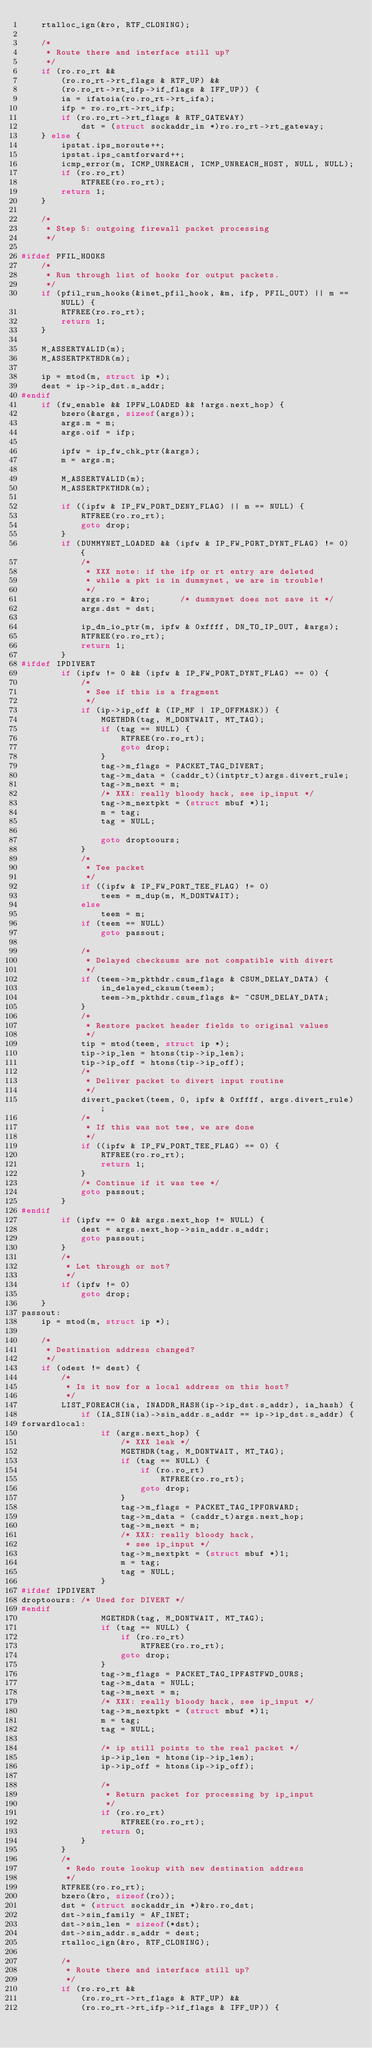Convert code to text. <code><loc_0><loc_0><loc_500><loc_500><_C_>	rtalloc_ign(&ro, RTF_CLONING);

	/*
	 * Route there and interface still up?
	 */
	if (ro.ro_rt &&
	    (ro.ro_rt->rt_flags & RTF_UP) &&
	    (ro.ro_rt->rt_ifp->if_flags & IFF_UP)) {
		ia = ifatoia(ro.ro_rt->rt_ifa);
		ifp = ro.ro_rt->rt_ifp;
		if (ro.ro_rt->rt_flags & RTF_GATEWAY)
			dst = (struct sockaddr_in *)ro.ro_rt->rt_gateway;
	} else {
		ipstat.ips_noroute++;
		ipstat.ips_cantforward++;
		icmp_error(m, ICMP_UNREACH, ICMP_UNREACH_HOST, NULL, NULL);
		if (ro.ro_rt)
			RTFREE(ro.ro_rt);
		return 1;
	}

	/*
	 * Step 5: outgoing firewall packet processing
	 */

#ifdef PFIL_HOOKS
	/*
	 * Run through list of hooks for output packets.
	 */
	if (pfil_run_hooks(&inet_pfil_hook, &m, ifp, PFIL_OUT) || m == NULL) {
		RTFREE(ro.ro_rt);
		return 1;
	}

	M_ASSERTVALID(m);
	M_ASSERTPKTHDR(m);

	ip = mtod(m, struct ip *);
	dest = ip->ip_dst.s_addr;
#endif
	if (fw_enable && IPFW_LOADED && !args.next_hop) {
		bzero(&args, sizeof(args));
		args.m = m;
		args.oif = ifp;

		ipfw = ip_fw_chk_ptr(&args);
		m = args.m;

		M_ASSERTVALID(m);
		M_ASSERTPKTHDR(m);

		if ((ipfw & IP_FW_PORT_DENY_FLAG) || m == NULL) {
			RTFREE(ro.ro_rt);
			goto drop;
		}
		if (DUMMYNET_LOADED && (ipfw & IP_FW_PORT_DYNT_FLAG) != 0) {
			/*
			 * XXX note: if the ifp or rt entry are deleted
			 * while a pkt is in dummynet, we are in trouble!
			 */
			args.ro = &ro;		/* dummynet does not save it */
			args.dst = dst;

			ip_dn_io_ptr(m, ipfw & 0xffff, DN_TO_IP_OUT, &args);
			RTFREE(ro.ro_rt);
			return 1;
		}
#ifdef IPDIVERT
		if (ipfw != 0 && (ipfw & IP_FW_PORT_DYNT_FLAG) == 0) {
			/*
			 * See if this is a fragment
			 */
			if (ip->ip_off & (IP_MF | IP_OFFMASK)) {
				MGETHDR(tag, M_DONTWAIT, MT_TAG);
				if (tag == NULL) {
					RTFREE(ro.ro_rt);
					goto drop;
				}
				tag->m_flags = PACKET_TAG_DIVERT;
				tag->m_data = (caddr_t)(intptr_t)args.divert_rule;
				tag->m_next = m;
				/* XXX: really bloody hack, see ip_input */
				tag->m_nextpkt = (struct mbuf *)1;
				m = tag;
				tag = NULL;

				goto droptoours;
			}
			/*
			 * Tee packet
			 */
			if ((ipfw & IP_FW_PORT_TEE_FLAG) != 0)
				teem = m_dup(m, M_DONTWAIT);
			else
				teem = m;
			if (teem == NULL)
				goto passout;

			/*
			 * Delayed checksums are not compatible with divert
			 */
			if (teem->m_pkthdr.csum_flags & CSUM_DELAY_DATA) {
				in_delayed_cksum(teem);
				teem->m_pkthdr.csum_flags &= ~CSUM_DELAY_DATA;
			}
			/*
			 * Restore packet header fields to original values
			 */
			tip = mtod(teem, struct ip *);
			tip->ip_len = htons(tip->ip_len);
			tip->ip_off = htons(tip->ip_off);
			/*
			 * Deliver packet to divert input routine
			 */
			divert_packet(teem, 0, ipfw & 0xffff, args.divert_rule);
			/*
			 * If this was not tee, we are done
			 */
			if ((ipfw & IP_FW_PORT_TEE_FLAG) == 0) {
				RTFREE(ro.ro_rt);
				return 1;
			}
			/* Continue if it was tee */
			goto passout;
		}
#endif
		if (ipfw == 0 && args.next_hop != NULL) {
			dest = args.next_hop->sin_addr.s_addr;
			goto passout;
		}
		/*
		 * Let through or not?
		 */
		if (ipfw != 0)
			goto drop;
	}
passout:
	ip = mtod(m, struct ip *);

	/*
	 * Destination address changed?
	 */
	if (odest != dest) {
		/*
		 * Is it now for a local address on this host?
		 */
		LIST_FOREACH(ia, INADDR_HASH(ip->ip_dst.s_addr), ia_hash) {
			if (IA_SIN(ia)->sin_addr.s_addr == ip->ip_dst.s_addr) {
forwardlocal:
				if (args.next_hop) {
					/* XXX leak */
					MGETHDR(tag, M_DONTWAIT, MT_TAG);
					if (tag == NULL) {
						if (ro.ro_rt)
							RTFREE(ro.ro_rt);
						goto drop;
					}
					tag->m_flags = PACKET_TAG_IPFORWARD;
					tag->m_data = (caddr_t)args.next_hop;
					tag->m_next = m;
					/* XXX: really bloody hack,
					 * see ip_input */
					tag->m_nextpkt = (struct mbuf *)1;
					m = tag;
					tag = NULL;
				}
#ifdef IPDIVERT
droptoours:	/* Used for DIVERT */
#endif
				MGETHDR(tag, M_DONTWAIT, MT_TAG);
				if (tag == NULL) {
					if (ro.ro_rt)
						RTFREE(ro.ro_rt);
					goto drop;
				}
				tag->m_flags = PACKET_TAG_IPFASTFWD_OURS;
				tag->m_data = NULL;
				tag->m_next = m;
				/* XXX: really bloody hack, see ip_input */
				tag->m_nextpkt = (struct mbuf *)1;
				m = tag;
				tag = NULL;

				/* ip still points to the real packet */
				ip->ip_len = htons(ip->ip_len);
				ip->ip_off = htons(ip->ip_off);

				/*
				 * Return packet for processing by ip_input
				 */
				if (ro.ro_rt)
					RTFREE(ro.ro_rt);
				return 0;
			}
		}
		/*
		 * Redo route lookup with new destination address
		 */
		RTFREE(ro.ro_rt);
		bzero(&ro, sizeof(ro));
		dst = (struct sockaddr_in *)&ro.ro_dst;
		dst->sin_family = AF_INET;
		dst->sin_len = sizeof(*dst);
		dst->sin_addr.s_addr = dest;
		rtalloc_ign(&ro, RTF_CLONING);

		/*
		 * Route there and interface still up?
		 */
		if (ro.ro_rt &&
		    (ro.ro_rt->rt_flags & RTF_UP) &&
		    (ro.ro_rt->rt_ifp->if_flags & IFF_UP)) {</code> 